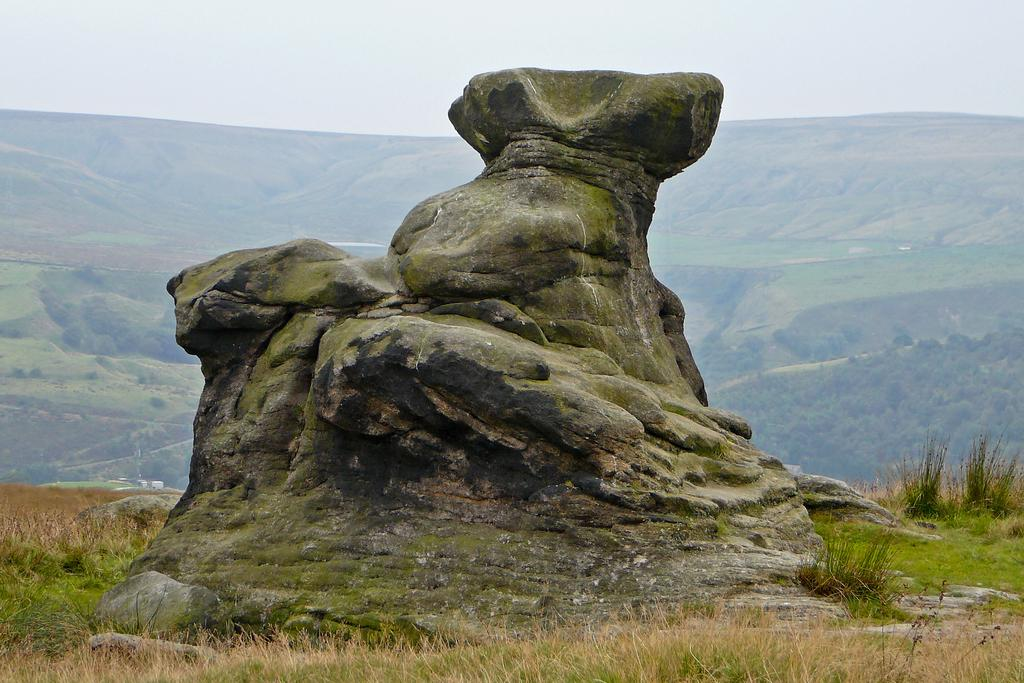What is the main object in the image? There is a rock in the image. What type of vegetation can be seen in the image? There is grass in the image. What can be seen in the background of the image? There is a hill, trees, and the sky visible in the background of the image. What type of fish can be seen swimming in the paper in the image? There is no fish or paper present in the image; it features a rock, grass, and a background with a hill, trees, and the sky. 